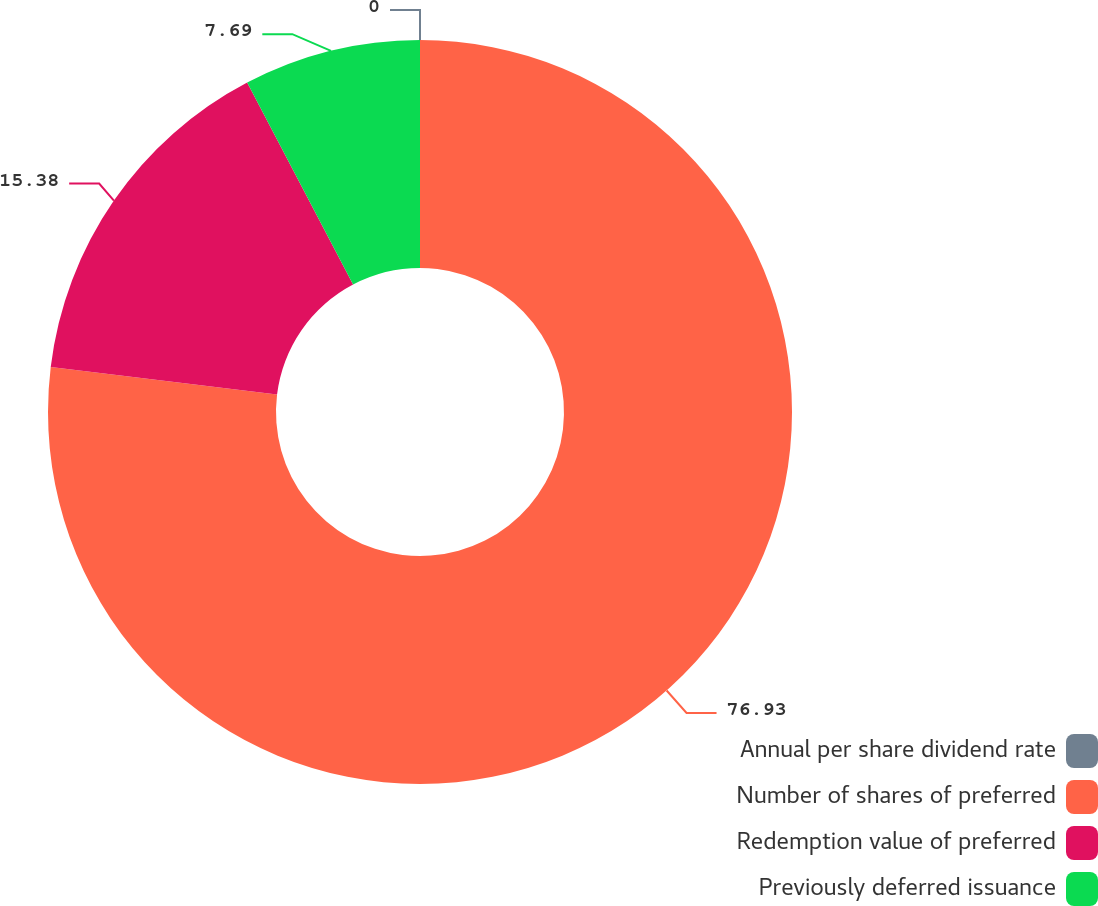<chart> <loc_0><loc_0><loc_500><loc_500><pie_chart><fcel>Annual per share dividend rate<fcel>Number of shares of preferred<fcel>Redemption value of preferred<fcel>Previously deferred issuance<nl><fcel>0.0%<fcel>76.92%<fcel>15.38%<fcel>7.69%<nl></chart> 